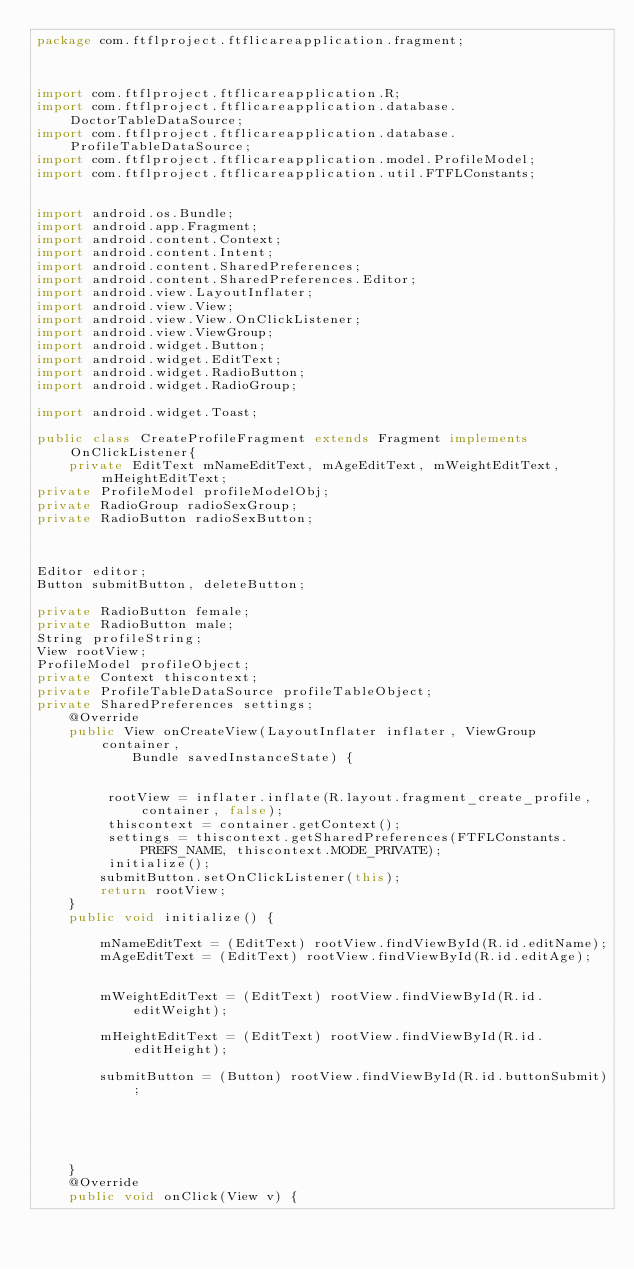<code> <loc_0><loc_0><loc_500><loc_500><_Java_>package com.ftflproject.ftflicareapplication.fragment;



import com.ftflproject.ftflicareapplication.R;
import com.ftflproject.ftflicareapplication.database.DoctorTableDataSource;
import com.ftflproject.ftflicareapplication.database.ProfileTableDataSource;
import com.ftflproject.ftflicareapplication.model.ProfileModel;
import com.ftflproject.ftflicareapplication.util.FTFLConstants;


import android.os.Bundle;
import android.app.Fragment;
import android.content.Context;
import android.content.Intent;
import android.content.SharedPreferences;
import android.content.SharedPreferences.Editor;
import android.view.LayoutInflater;
import android.view.View;
import android.view.View.OnClickListener;
import android.view.ViewGroup;
import android.widget.Button;
import android.widget.EditText;
import android.widget.RadioButton;
import android.widget.RadioGroup;

import android.widget.Toast;

public class CreateProfileFragment extends Fragment implements OnClickListener{
	private EditText mNameEditText, mAgeEditText, mWeightEditText, mHeightEditText;
private ProfileModel profileModelObj;
private RadioGroup radioSexGroup;
private RadioButton radioSexButton;



Editor editor;
Button submitButton, deleteButton;

private RadioButton female;
private RadioButton male;
String profileString;
View rootView;
ProfileModel profileObject;
private Context thiscontext;
private ProfileTableDataSource profileTableObject;
private SharedPreferences settings;
	@Override
	public View onCreateView(LayoutInflater inflater, ViewGroup container,
			Bundle savedInstanceState) {
		
		
		 rootView = inflater.inflate(R.layout.fragment_create_profile, container, false);
		 thiscontext = container.getContext();
		 settings = thiscontext.getSharedPreferences(FTFLConstants.PREFS_NAME, thiscontext.MODE_PRIVATE);
		 initialize();
		submitButton.setOnClickListener(this);
        return rootView;
	}
	public void initialize() {

		mNameEditText = (EditText) rootView.findViewById(R.id.editName);
		mAgeEditText = (EditText) rootView.findViewById(R.id.editAge);

		
		mWeightEditText = (EditText) rootView.findViewById(R.id.editWeight);
		
		mHeightEditText = (EditText) rootView.findViewById(R.id.editHeight);
		
		submitButton = (Button) rootView.findViewById(R.id.buttonSubmit);
		
		
		
		

	}
	@Override
	public void onClick(View v) {</code> 